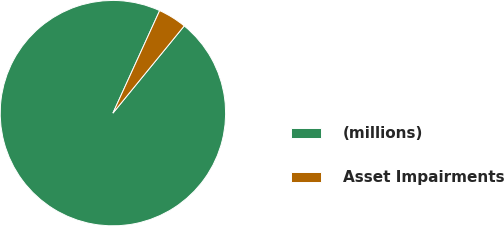Convert chart. <chart><loc_0><loc_0><loc_500><loc_500><pie_chart><fcel>(millions)<fcel>Asset Impairments<nl><fcel>95.9%<fcel>4.1%<nl></chart> 